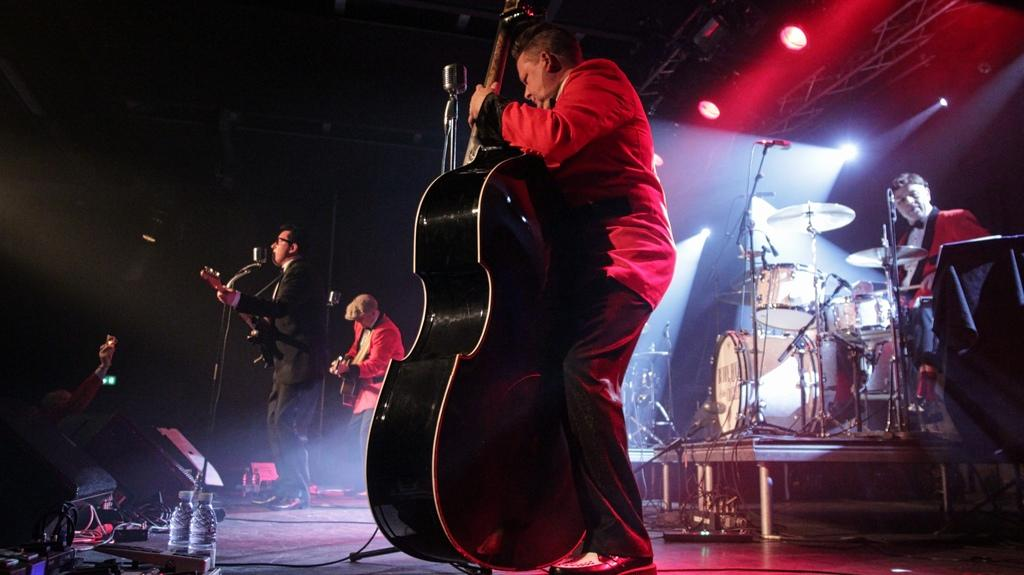What are the people in the image doing? The people in the image are playing musical instruments. Where are the people located in the image? The people are on a stage. What might be the purpose of the people being on a stage? The people might be performing a concert or a musical event. What type of spoon is being used by the people on the stage? There is no spoon present in the image; the people are playing musical instruments. 